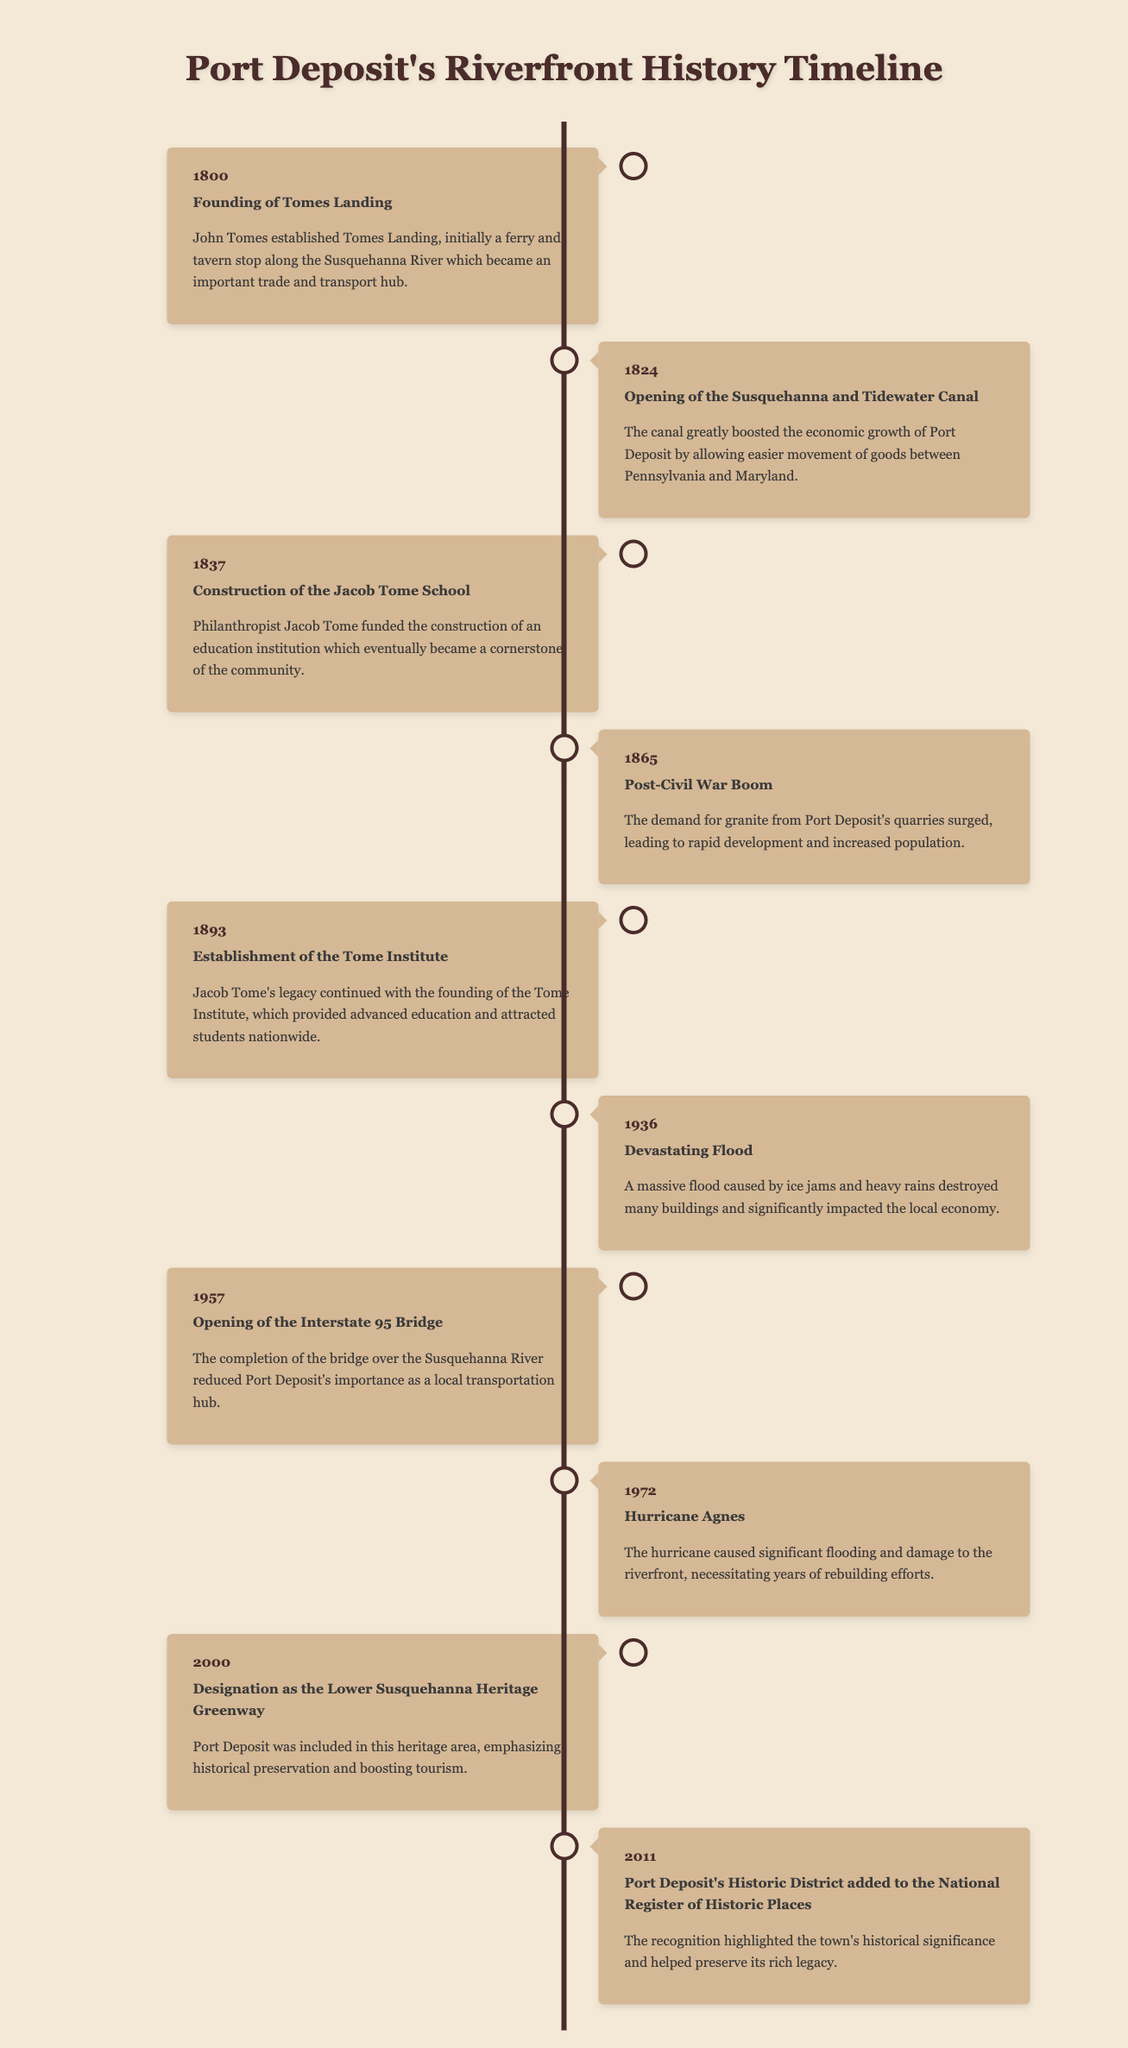What year was Tomes Landing founded? The document states that Tomes Landing was founded in 1800.
Answer: 1800 What significant construction took place in 1837? The timeline indicates that the Jacob Tome School was constructed in 1837.
Answer: Jacob Tome School Which event in 1865 led to rapid population growth? The post-Civil War boom in 1865 caused a surge in granite demand, leading to increased population.
Answer: Post-Civil War Boom What flood event occurred in 1936? The document mentions a devastating flood that took place in 1936.
Answer: Devastating Flood Which bridge was opened in 1957? The timeline notes the opening of the Interstate 95 Bridge in 1957.
Answer: Interstate 95 Bridge How many years later was Port Deposit designated as the Lower Susquehanna Heritage Greenway compared to the founding of Tomes Landing? The designation occurred in 2000, which is 200 years after 1800.
Answer: 200 years What recognition did Port Deposit receive in 2011? The timeline states that Port Deposit's Historic District was added to the National Register of Historic Places in 2011.
Answer: National Register of Historic Places Which event caused significant rebuilding efforts in Port Deposit? The document indicates Hurricane Agnes in 1972 necessitated extensive rebuilding efforts.
Answer: Hurricane Agnes 